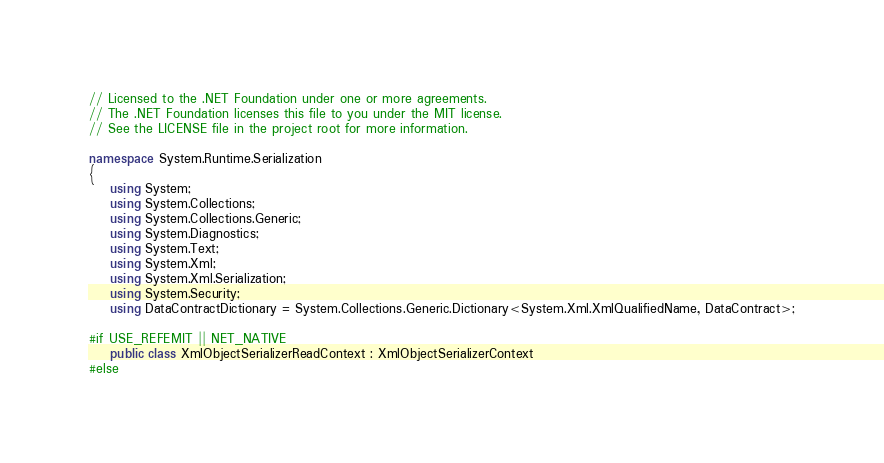Convert code to text. <code><loc_0><loc_0><loc_500><loc_500><_C#_>// Licensed to the .NET Foundation under one or more agreements.
// The .NET Foundation licenses this file to you under the MIT license.
// See the LICENSE file in the project root for more information.

namespace System.Runtime.Serialization
{
    using System;
    using System.Collections;
    using System.Collections.Generic;
    using System.Diagnostics;
    using System.Text;
    using System.Xml;
    using System.Xml.Serialization;
    using System.Security;
    using DataContractDictionary = System.Collections.Generic.Dictionary<System.Xml.XmlQualifiedName, DataContract>;

#if USE_REFEMIT || NET_NATIVE
    public class XmlObjectSerializerReadContext : XmlObjectSerializerContext
#else</code> 